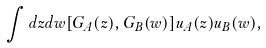Convert formula to latex. <formula><loc_0><loc_0><loc_500><loc_500>\int d z d w [ G _ { A } ( z ) , G _ { B } ( w ) ] u _ { A } ( z ) u _ { B } ( w ) ,</formula> 